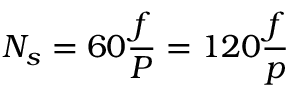Convert formula to latex. <formula><loc_0><loc_0><loc_500><loc_500>N _ { s } = 6 0 { \frac { f } { P } } = 1 2 0 { \frac { f } { p } }</formula> 